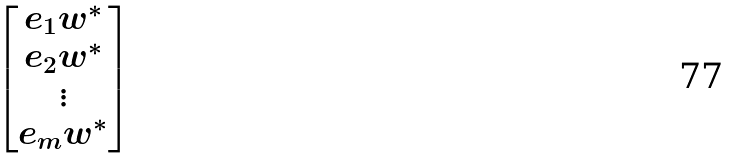<formula> <loc_0><loc_0><loc_500><loc_500>\begin{bmatrix} e _ { 1 } w ^ { * } \\ e _ { 2 } w ^ { * } \\ \vdots \\ e _ { m } w ^ { * } \end{bmatrix}</formula> 